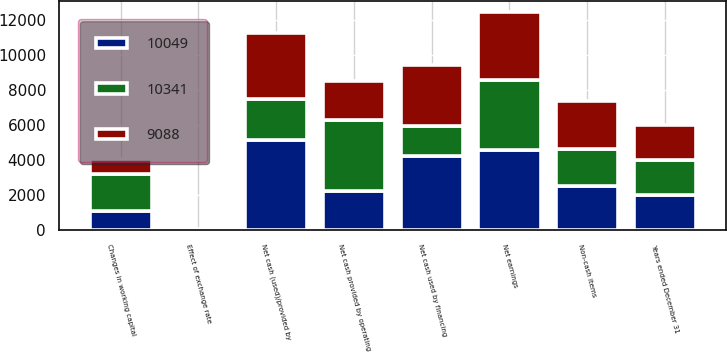<chart> <loc_0><loc_0><loc_500><loc_500><stacked_bar_chart><ecel><fcel>Years ended December 31<fcel>Net earnings<fcel>Non-cash items<fcel>Changes in working capital<fcel>Net cash provided by operating<fcel>Net cash (used)/provided by<fcel>Net cash used by financing<fcel>Effect of exchange rate<nl><fcel>10049<fcel>2013<fcel>4585<fcel>2516<fcel>1078<fcel>2254.5<fcel>5154<fcel>4249<fcel>29<nl><fcel>9088<fcel>2012<fcel>3900<fcel>2728<fcel>880<fcel>2254.5<fcel>3757<fcel>3477<fcel>18<nl><fcel>10341<fcel>2011<fcel>4018<fcel>2140<fcel>2135<fcel>4023<fcel>2369<fcel>1700<fcel>2<nl></chart> 